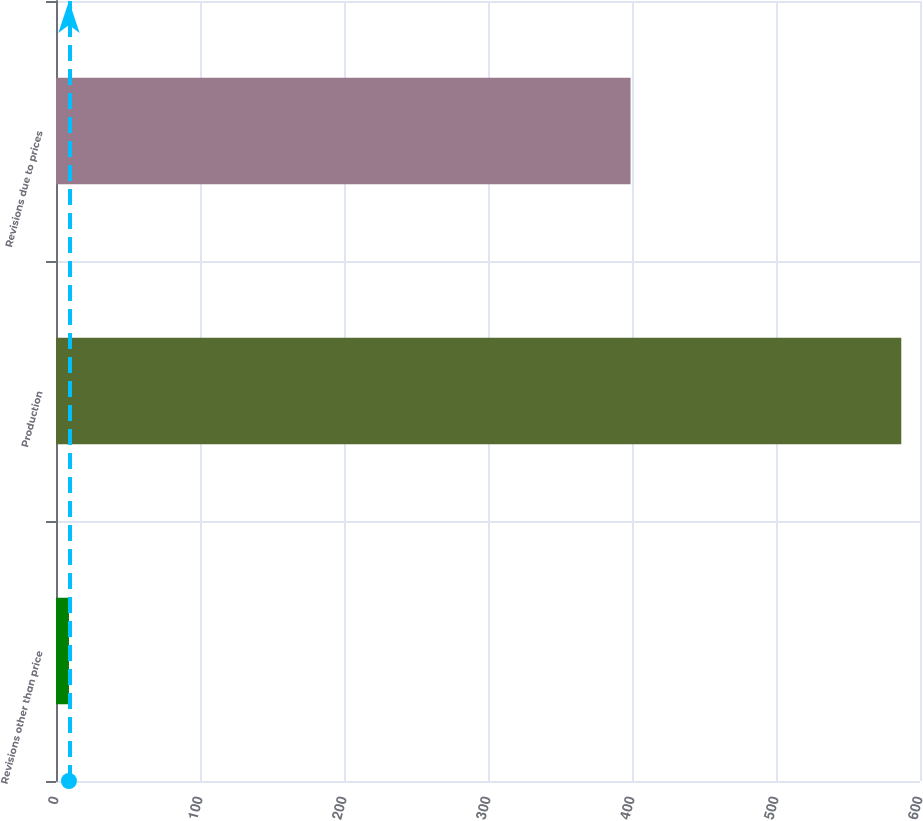Convert chart to OTSL. <chart><loc_0><loc_0><loc_500><loc_500><bar_chart><fcel>Revisions other than price<fcel>Production<fcel>Revisions due to prices<nl><fcel>9<fcel>587<fcel>399<nl></chart> 